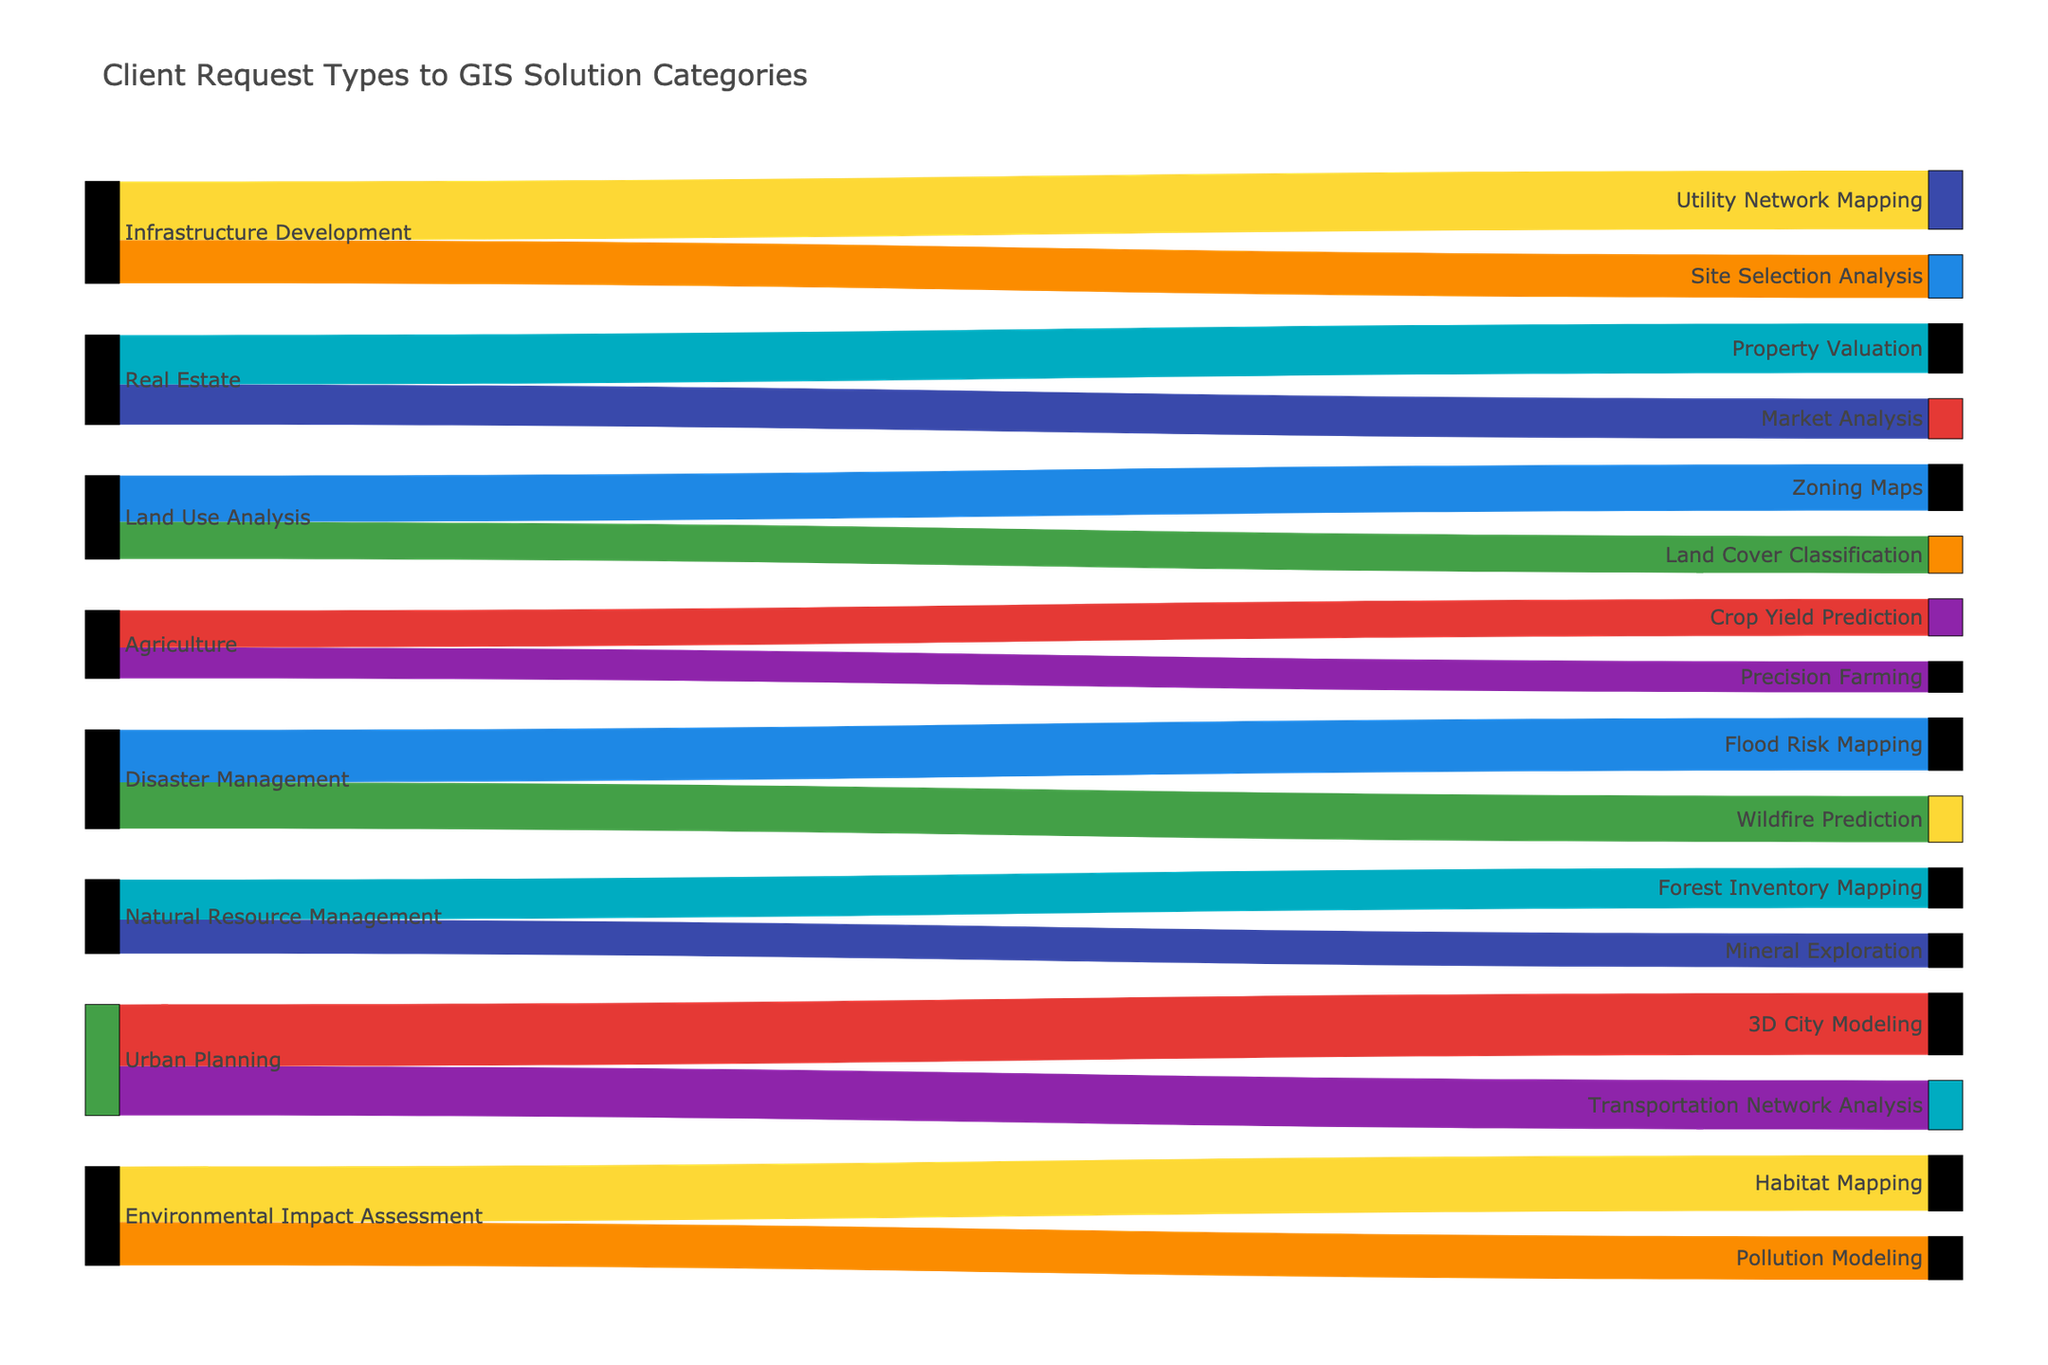What are the request types being analyzed in the diagram? The request types are the sources in the Sankey diagram. Identifying these from the figure, they include Land Use Analysis, Environmental Impact Assessment, Urban Planning, Natural Resource Management, Disaster Management, Infrastructure Development, Agriculture, and Real Estate.
Answer: Land Use Analysis, Environmental Impact Assessment, Urban Planning, Natural Resource Management, Disaster Management, Infrastructure Development, Agriculture, Real Estate Which request type has the largest total flow value? To determine this, we need to sum the values flowing from each source. Urban Planning has two flows of 20 and 16, totaling 36, which is the highest among all the request types.
Answer: Urban Planning What solution category receives the highest number of flows from request types? We count the number of flows directed toward each target. The solution categories Flood Risk Mapping, Wildfire Prediction, 3D City Modeling, Property Valuation, and Utility Network Mapping each have one flow, while the others have different counts.
Answer: 3D City Modeling, Property Valuation, Utility Network Mapping (all have one) Which request type has the smallest total flow value, and what is the total? Summing the values for each request type, Agriculture has flow values of 12 and 10, totaling 22. This is the smallest compared to other request types.
Answer: Agriculture, 22 How many total solution categories are depicted in the diagram? The solution categories are the targets in the Sankey diagram. By counting these distinct categories, we identify sixteen unique solution categories.
Answer: Sixteen What's the total value flowing into Natural Resource Management? Summing the flows for Natural Resource Management, we have Forest Inventory Mapping with a value of 13 and Mineral Exploration with 11. Therefore, the total flow is 13 + 11 = 24.
Answer: 24 Compare the total flow values between Disaster Management and Infrastructure Development. Disaster Management has flows of 17 and 15, summing to 32. Infrastructure Development has flows of 19 and 14, also summing to 33. Thus, Infrastructure Development has a slightly larger total flow than Disaster Management.
Answer: Infrastructure Development, 33 vs. Disaster Management, 32 Which solution categories receive flows from Environmental Impact Assessment? Environmental Impact Assessment has flows directed towards Habitat Mapping and Pollution Modeling.
Answer: Habitat Mapping, Pollution Modeling What are the values of flows originating from Real Estate? The flows originating from Real Estate target Property Valuation with a value of 16 and Market Analysis with a value of 13.
Answer: 16, 13 Summarize the information portrayed in the diagram. The diagram shows how different client request types lead to specific GIS solution categories. It visualizes the distribution and magnitude of requests across various solutions, helping to understand demand patterns and resource allocation.
Answer: Various client requests lead to specific GIS solutions, visualizing demand patterns and resource allocation 